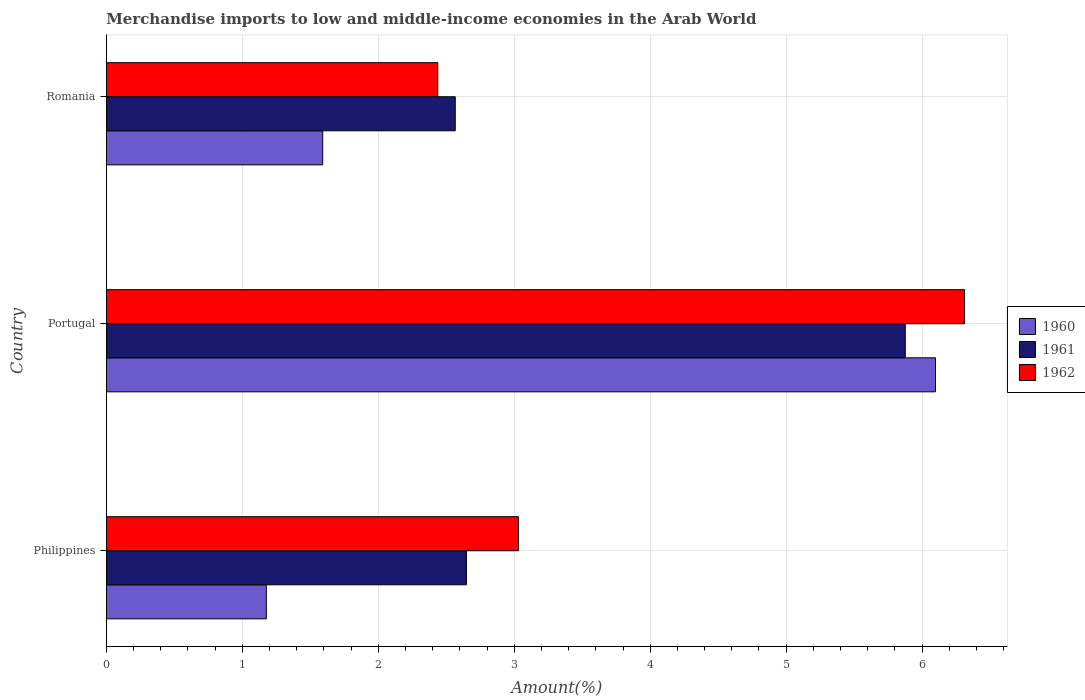How many groups of bars are there?
Provide a succinct answer. 3. How many bars are there on the 1st tick from the bottom?
Your answer should be very brief. 3. What is the percentage of amount earned from merchandise imports in 1962 in Philippines?
Offer a very short reply. 3.03. Across all countries, what is the maximum percentage of amount earned from merchandise imports in 1961?
Your answer should be very brief. 5.88. Across all countries, what is the minimum percentage of amount earned from merchandise imports in 1960?
Keep it short and to the point. 1.18. In which country was the percentage of amount earned from merchandise imports in 1960 maximum?
Your answer should be compact. Portugal. In which country was the percentage of amount earned from merchandise imports in 1960 minimum?
Provide a succinct answer. Philippines. What is the total percentage of amount earned from merchandise imports in 1962 in the graph?
Offer a very short reply. 11.78. What is the difference between the percentage of amount earned from merchandise imports in 1960 in Portugal and that in Romania?
Your answer should be very brief. 4.51. What is the difference between the percentage of amount earned from merchandise imports in 1962 in Philippines and the percentage of amount earned from merchandise imports in 1960 in Portugal?
Offer a terse response. -3.07. What is the average percentage of amount earned from merchandise imports in 1960 per country?
Keep it short and to the point. 2.96. What is the difference between the percentage of amount earned from merchandise imports in 1961 and percentage of amount earned from merchandise imports in 1960 in Portugal?
Provide a succinct answer. -0.22. In how many countries, is the percentage of amount earned from merchandise imports in 1962 greater than 0.8 %?
Make the answer very short. 3. What is the ratio of the percentage of amount earned from merchandise imports in 1960 in Philippines to that in Portugal?
Provide a succinct answer. 0.19. Is the percentage of amount earned from merchandise imports in 1962 in Philippines less than that in Portugal?
Offer a terse response. Yes. What is the difference between the highest and the second highest percentage of amount earned from merchandise imports in 1960?
Make the answer very short. 4.51. What is the difference between the highest and the lowest percentage of amount earned from merchandise imports in 1962?
Provide a short and direct response. 3.87. Is the sum of the percentage of amount earned from merchandise imports in 1962 in Philippines and Romania greater than the maximum percentage of amount earned from merchandise imports in 1960 across all countries?
Provide a succinct answer. No. What does the 3rd bar from the bottom in Philippines represents?
Provide a short and direct response. 1962. Is it the case that in every country, the sum of the percentage of amount earned from merchandise imports in 1962 and percentage of amount earned from merchandise imports in 1960 is greater than the percentage of amount earned from merchandise imports in 1961?
Provide a short and direct response. Yes. How many countries are there in the graph?
Keep it short and to the point. 3. What is the difference between two consecutive major ticks on the X-axis?
Offer a terse response. 1. Does the graph contain any zero values?
Offer a very short reply. No. Where does the legend appear in the graph?
Ensure brevity in your answer.  Center right. How many legend labels are there?
Give a very brief answer. 3. How are the legend labels stacked?
Your answer should be compact. Vertical. What is the title of the graph?
Provide a succinct answer. Merchandise imports to low and middle-income economies in the Arab World. Does "1996" appear as one of the legend labels in the graph?
Your answer should be compact. No. What is the label or title of the X-axis?
Provide a succinct answer. Amount(%). What is the Amount(%) of 1960 in Philippines?
Offer a very short reply. 1.18. What is the Amount(%) in 1961 in Philippines?
Provide a short and direct response. 2.65. What is the Amount(%) in 1962 in Philippines?
Your answer should be compact. 3.03. What is the Amount(%) in 1960 in Portugal?
Give a very brief answer. 6.1. What is the Amount(%) of 1961 in Portugal?
Your answer should be very brief. 5.88. What is the Amount(%) of 1962 in Portugal?
Your answer should be compact. 6.31. What is the Amount(%) of 1960 in Romania?
Keep it short and to the point. 1.59. What is the Amount(%) in 1961 in Romania?
Give a very brief answer. 2.57. What is the Amount(%) in 1962 in Romania?
Provide a succinct answer. 2.44. Across all countries, what is the maximum Amount(%) of 1960?
Your answer should be compact. 6.1. Across all countries, what is the maximum Amount(%) in 1961?
Make the answer very short. 5.88. Across all countries, what is the maximum Amount(%) in 1962?
Offer a terse response. 6.31. Across all countries, what is the minimum Amount(%) in 1960?
Offer a terse response. 1.18. Across all countries, what is the minimum Amount(%) in 1961?
Ensure brevity in your answer.  2.57. Across all countries, what is the minimum Amount(%) of 1962?
Keep it short and to the point. 2.44. What is the total Amount(%) in 1960 in the graph?
Your answer should be compact. 8.87. What is the total Amount(%) in 1961 in the graph?
Your answer should be very brief. 11.09. What is the total Amount(%) of 1962 in the graph?
Your answer should be very brief. 11.78. What is the difference between the Amount(%) of 1960 in Philippines and that in Portugal?
Give a very brief answer. -4.92. What is the difference between the Amount(%) in 1961 in Philippines and that in Portugal?
Your answer should be very brief. -3.23. What is the difference between the Amount(%) of 1962 in Philippines and that in Portugal?
Provide a short and direct response. -3.28. What is the difference between the Amount(%) of 1960 in Philippines and that in Romania?
Your answer should be very brief. -0.41. What is the difference between the Amount(%) in 1961 in Philippines and that in Romania?
Make the answer very short. 0.08. What is the difference between the Amount(%) in 1962 in Philippines and that in Romania?
Give a very brief answer. 0.59. What is the difference between the Amount(%) of 1960 in Portugal and that in Romania?
Ensure brevity in your answer.  4.51. What is the difference between the Amount(%) in 1961 in Portugal and that in Romania?
Ensure brevity in your answer.  3.31. What is the difference between the Amount(%) of 1962 in Portugal and that in Romania?
Offer a very short reply. 3.87. What is the difference between the Amount(%) of 1960 in Philippines and the Amount(%) of 1961 in Portugal?
Your answer should be compact. -4.7. What is the difference between the Amount(%) of 1960 in Philippines and the Amount(%) of 1962 in Portugal?
Keep it short and to the point. -5.13. What is the difference between the Amount(%) of 1961 in Philippines and the Amount(%) of 1962 in Portugal?
Make the answer very short. -3.66. What is the difference between the Amount(%) in 1960 in Philippines and the Amount(%) in 1961 in Romania?
Offer a very short reply. -1.39. What is the difference between the Amount(%) of 1960 in Philippines and the Amount(%) of 1962 in Romania?
Give a very brief answer. -1.26. What is the difference between the Amount(%) of 1961 in Philippines and the Amount(%) of 1962 in Romania?
Provide a short and direct response. 0.21. What is the difference between the Amount(%) in 1960 in Portugal and the Amount(%) in 1961 in Romania?
Ensure brevity in your answer.  3.53. What is the difference between the Amount(%) in 1960 in Portugal and the Amount(%) in 1962 in Romania?
Your answer should be compact. 3.66. What is the difference between the Amount(%) of 1961 in Portugal and the Amount(%) of 1962 in Romania?
Your answer should be compact. 3.44. What is the average Amount(%) of 1960 per country?
Your answer should be compact. 2.96. What is the average Amount(%) in 1961 per country?
Keep it short and to the point. 3.7. What is the average Amount(%) of 1962 per country?
Offer a terse response. 3.93. What is the difference between the Amount(%) of 1960 and Amount(%) of 1961 in Philippines?
Your answer should be compact. -1.47. What is the difference between the Amount(%) in 1960 and Amount(%) in 1962 in Philippines?
Offer a very short reply. -1.85. What is the difference between the Amount(%) of 1961 and Amount(%) of 1962 in Philippines?
Make the answer very short. -0.38. What is the difference between the Amount(%) in 1960 and Amount(%) in 1961 in Portugal?
Your response must be concise. 0.22. What is the difference between the Amount(%) in 1960 and Amount(%) in 1962 in Portugal?
Your response must be concise. -0.21. What is the difference between the Amount(%) of 1961 and Amount(%) of 1962 in Portugal?
Ensure brevity in your answer.  -0.44. What is the difference between the Amount(%) in 1960 and Amount(%) in 1961 in Romania?
Offer a very short reply. -0.97. What is the difference between the Amount(%) in 1960 and Amount(%) in 1962 in Romania?
Make the answer very short. -0.85. What is the difference between the Amount(%) of 1961 and Amount(%) of 1962 in Romania?
Give a very brief answer. 0.13. What is the ratio of the Amount(%) in 1960 in Philippines to that in Portugal?
Provide a succinct answer. 0.19. What is the ratio of the Amount(%) in 1961 in Philippines to that in Portugal?
Make the answer very short. 0.45. What is the ratio of the Amount(%) in 1962 in Philippines to that in Portugal?
Make the answer very short. 0.48. What is the ratio of the Amount(%) in 1960 in Philippines to that in Romania?
Your answer should be compact. 0.74. What is the ratio of the Amount(%) of 1961 in Philippines to that in Romania?
Offer a very short reply. 1.03. What is the ratio of the Amount(%) of 1962 in Philippines to that in Romania?
Your response must be concise. 1.24. What is the ratio of the Amount(%) of 1960 in Portugal to that in Romania?
Keep it short and to the point. 3.83. What is the ratio of the Amount(%) in 1961 in Portugal to that in Romania?
Offer a terse response. 2.29. What is the ratio of the Amount(%) in 1962 in Portugal to that in Romania?
Give a very brief answer. 2.59. What is the difference between the highest and the second highest Amount(%) of 1960?
Keep it short and to the point. 4.51. What is the difference between the highest and the second highest Amount(%) in 1961?
Provide a short and direct response. 3.23. What is the difference between the highest and the second highest Amount(%) of 1962?
Provide a succinct answer. 3.28. What is the difference between the highest and the lowest Amount(%) of 1960?
Your response must be concise. 4.92. What is the difference between the highest and the lowest Amount(%) in 1961?
Your answer should be compact. 3.31. What is the difference between the highest and the lowest Amount(%) in 1962?
Offer a very short reply. 3.87. 